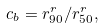<formula> <loc_0><loc_0><loc_500><loc_500>c _ { b } = r _ { 9 0 } ^ { r } / r _ { 5 0 } ^ { r } ,</formula> 